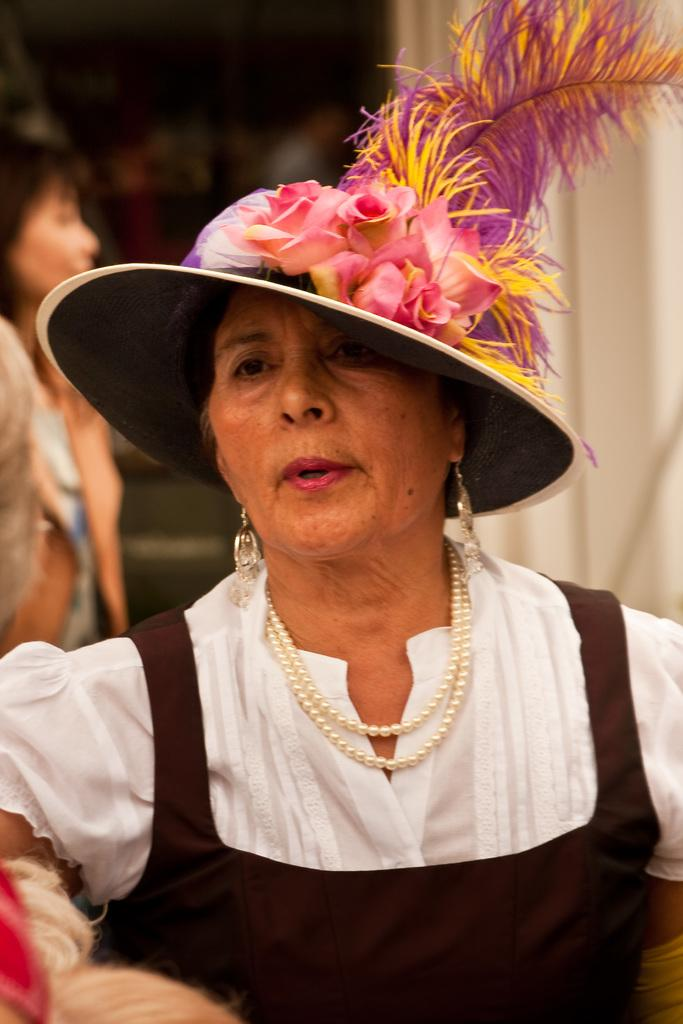How many people are in the image? There are people in the image, but the exact number is not specified. Can you describe any specific clothing or accessories worn by the people? Yes, one person is wearing a hat. What can be observed about the background of the image? The background of the image is blurred. What color is the object on the right side of the image? The object on the right side of the image is white. Can you tell me how many bats are flying in the image? There are no bats present in the image. What type of fish can be seen swimming in the image? There are no fish present in the image. 